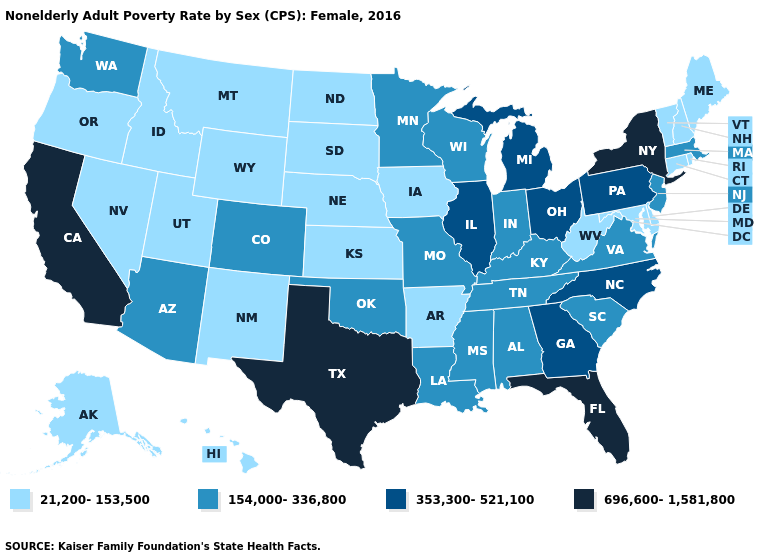Does Nevada have a lower value than California?
Write a very short answer. Yes. Name the states that have a value in the range 696,600-1,581,800?
Quick response, please. California, Florida, New York, Texas. Name the states that have a value in the range 21,200-153,500?
Write a very short answer. Alaska, Arkansas, Connecticut, Delaware, Hawaii, Idaho, Iowa, Kansas, Maine, Maryland, Montana, Nebraska, Nevada, New Hampshire, New Mexico, North Dakota, Oregon, Rhode Island, South Dakota, Utah, Vermont, West Virginia, Wyoming. Among the states that border New York , which have the highest value?
Give a very brief answer. Pennsylvania. Name the states that have a value in the range 696,600-1,581,800?
Be succinct. California, Florida, New York, Texas. Is the legend a continuous bar?
Keep it brief. No. What is the lowest value in states that border Indiana?
Answer briefly. 154,000-336,800. Name the states that have a value in the range 154,000-336,800?
Give a very brief answer. Alabama, Arizona, Colorado, Indiana, Kentucky, Louisiana, Massachusetts, Minnesota, Mississippi, Missouri, New Jersey, Oklahoma, South Carolina, Tennessee, Virginia, Washington, Wisconsin. Name the states that have a value in the range 353,300-521,100?
Quick response, please. Georgia, Illinois, Michigan, North Carolina, Ohio, Pennsylvania. What is the lowest value in the USA?
Be succinct. 21,200-153,500. Which states have the lowest value in the West?
Give a very brief answer. Alaska, Hawaii, Idaho, Montana, Nevada, New Mexico, Oregon, Utah, Wyoming. Name the states that have a value in the range 21,200-153,500?
Give a very brief answer. Alaska, Arkansas, Connecticut, Delaware, Hawaii, Idaho, Iowa, Kansas, Maine, Maryland, Montana, Nebraska, Nevada, New Hampshire, New Mexico, North Dakota, Oregon, Rhode Island, South Dakota, Utah, Vermont, West Virginia, Wyoming. Which states have the lowest value in the West?
Quick response, please. Alaska, Hawaii, Idaho, Montana, Nevada, New Mexico, Oregon, Utah, Wyoming. What is the lowest value in the USA?
Answer briefly. 21,200-153,500. Name the states that have a value in the range 154,000-336,800?
Keep it brief. Alabama, Arizona, Colorado, Indiana, Kentucky, Louisiana, Massachusetts, Minnesota, Mississippi, Missouri, New Jersey, Oklahoma, South Carolina, Tennessee, Virginia, Washington, Wisconsin. 